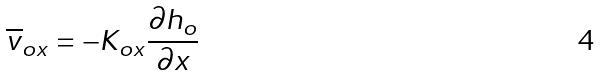Convert formula to latex. <formula><loc_0><loc_0><loc_500><loc_500>\overline { v } _ { o x } = - K _ { o x } \frac { \partial h _ { o } } { \partial x }</formula> 